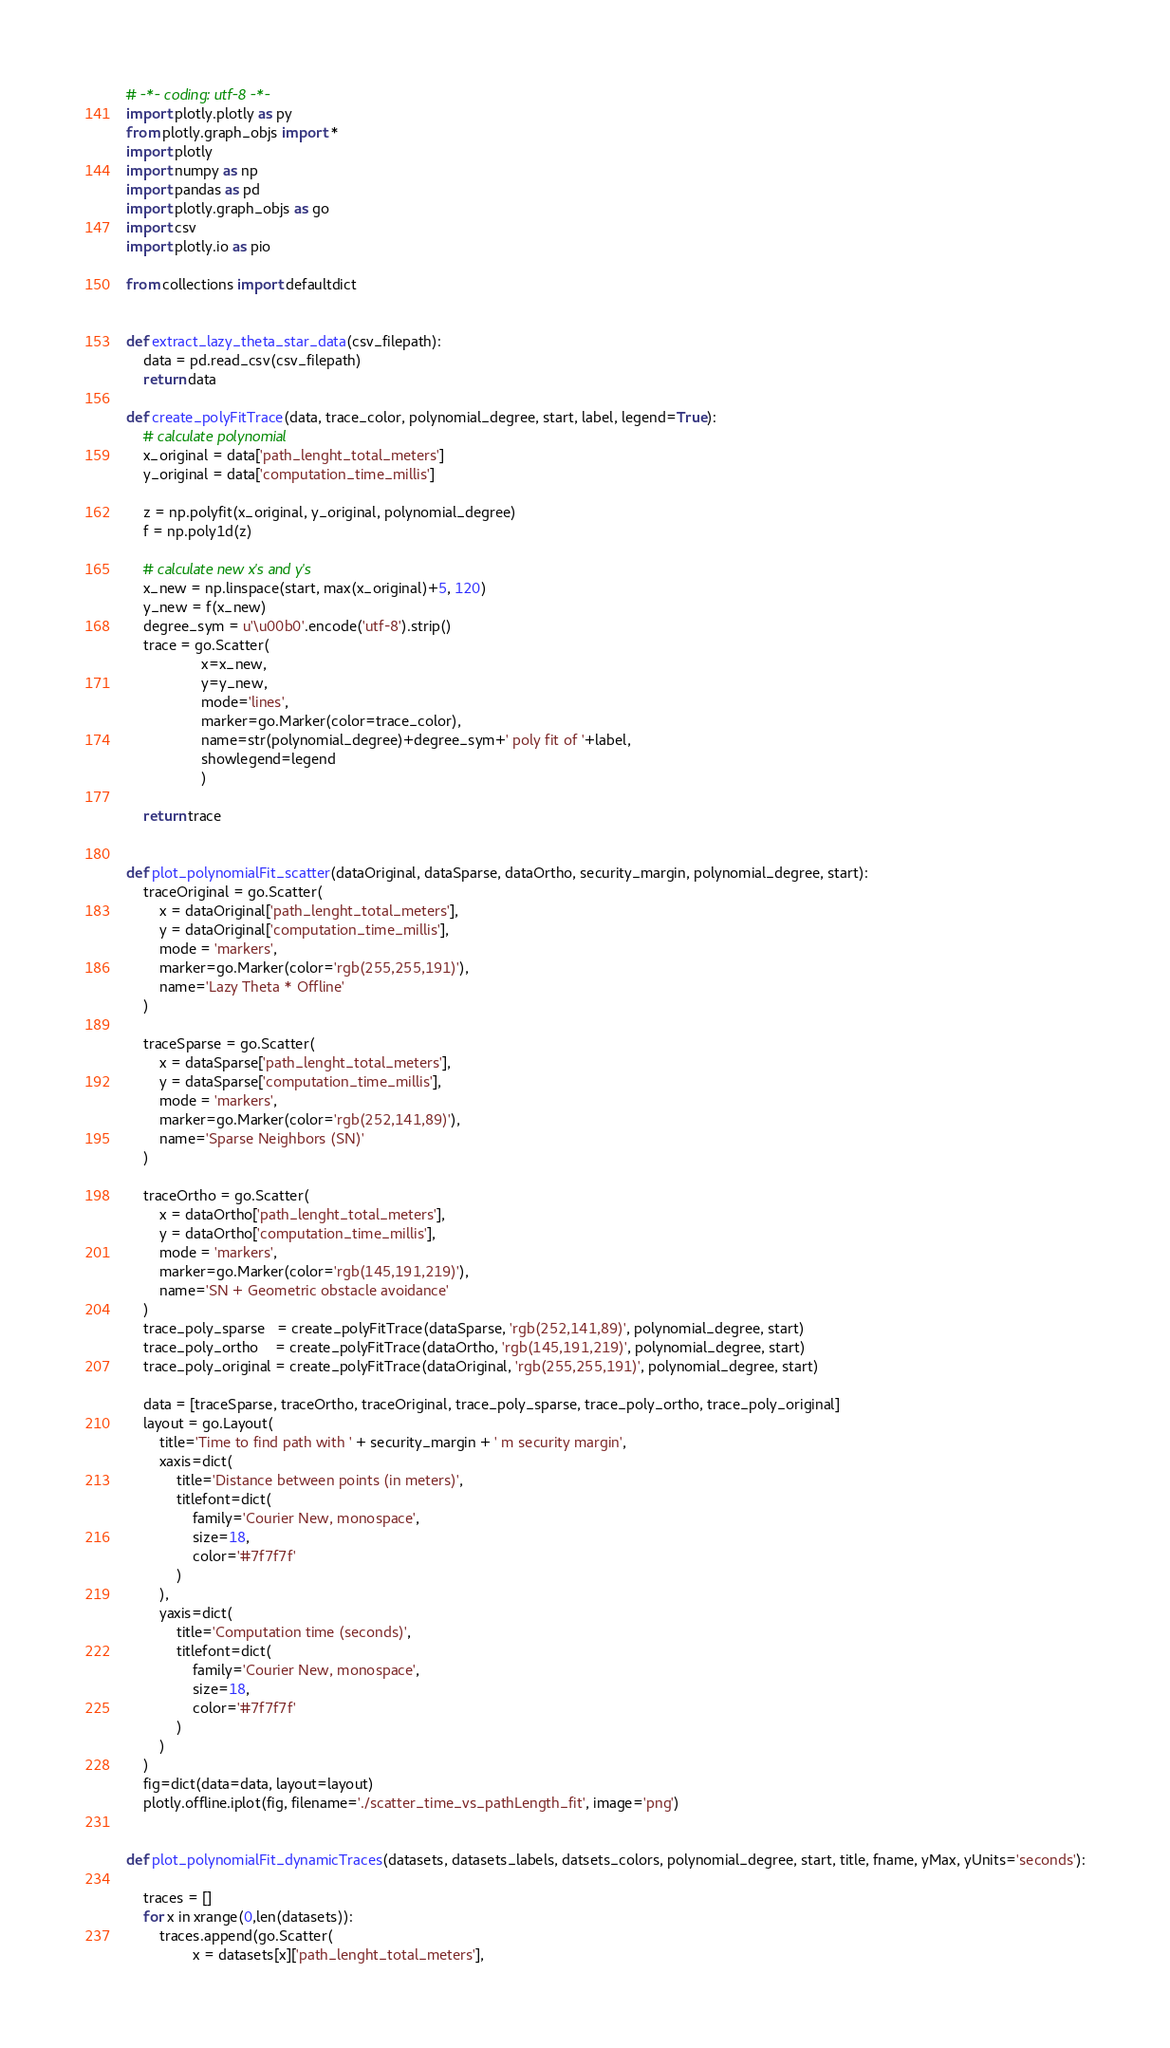Convert code to text. <code><loc_0><loc_0><loc_500><loc_500><_Python_># -*- coding: utf-8 -*-
import plotly.plotly as py
from plotly.graph_objs import *
import plotly
import numpy as np
import pandas as pd
import plotly.graph_objs as go
import csv
import plotly.io as pio

from collections import defaultdict

        
def extract_lazy_theta_star_data(csv_filepath):
    data = pd.read_csv(csv_filepath)
    return data

def create_polyFitTrace(data, trace_color, polynomial_degree, start, label, legend=True):
    # calculate polynomial
    x_original = data['path_lenght_total_meters']
    y_original = data['computation_time_millis']

    z = np.polyfit(x_original, y_original, polynomial_degree)
    f = np.poly1d(z)

    # calculate new x's and y's
    x_new = np.linspace(start, max(x_original)+5, 120)
    y_new = f(x_new)
    degree_sym = u'\u00b0'.encode('utf-8').strip()
    trace = go.Scatter(
                  x=x_new,
                  y=y_new,
                  mode='lines',
                  marker=go.Marker(color=trace_color),
                  name=str(polynomial_degree)+degree_sym+' poly fit of '+label,
                  showlegend=legend
                  )

    return trace


def plot_polynomialFit_scatter(dataOriginal, dataSparse, dataOrtho, security_margin, polynomial_degree, start):
    traceOriginal = go.Scatter(
        x = dataOriginal['path_lenght_total_meters'],
        y = dataOriginal['computation_time_millis'],
        mode = 'markers',
        marker=go.Marker(color='rgb(255,255,191)'),
        name='Lazy Theta * Offline'
    )

    traceSparse = go.Scatter(
        x = dataSparse['path_lenght_total_meters'],
        y = dataSparse['computation_time_millis'],
        mode = 'markers',
        marker=go.Marker(color='rgb(252,141,89)'),
        name='Sparse Neighbors (SN)'
    )

    traceOrtho = go.Scatter(
        x = dataOrtho['path_lenght_total_meters'],
        y = dataOrtho['computation_time_millis'],
        mode = 'markers',
        marker=go.Marker(color='rgb(145,191,219)'),
        name='SN + Geometric obstacle avoidance'
    )
    trace_poly_sparse   = create_polyFitTrace(dataSparse, 'rgb(252,141,89)', polynomial_degree, start)
    trace_poly_ortho    = create_polyFitTrace(dataOrtho, 'rgb(145,191,219)', polynomial_degree, start)
    trace_poly_original = create_polyFitTrace(dataOriginal, 'rgb(255,255,191)', polynomial_degree, start)

    data = [traceSparse, traceOrtho, traceOriginal, trace_poly_sparse, trace_poly_ortho, trace_poly_original]
    layout = go.Layout(
        title='Time to find path with ' + security_margin + ' m security margin',
        xaxis=dict(
            title='Distance between points (in meters)',
            titlefont=dict(
                family='Courier New, monospace',
                size=18,
                color='#7f7f7f'
            )
        ),
        yaxis=dict(
            title='Computation time (seconds)',
            titlefont=dict(
                family='Courier New, monospace',
                size=18,
                color='#7f7f7f'
            )
        )
    )
    fig=dict(data=data, layout=layout)
    plotly.offline.iplot(fig, filename='./scatter_time_vs_pathLength_fit', image='png')
    

def plot_polynomialFit_dynamicTraces(datasets, datasets_labels, datsets_colors, polynomial_degree, start, title, fname, yMax, yUnits='seconds'):

    traces = []
    for x in xrange(0,len(datasets)):
        traces.append(go.Scatter(
                x = datasets[x]['path_lenght_total_meters'],</code> 